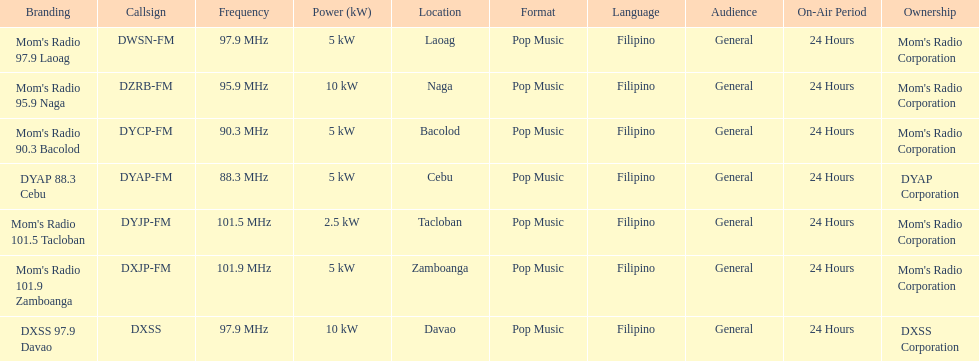What is the last location on this chart? Davao. 